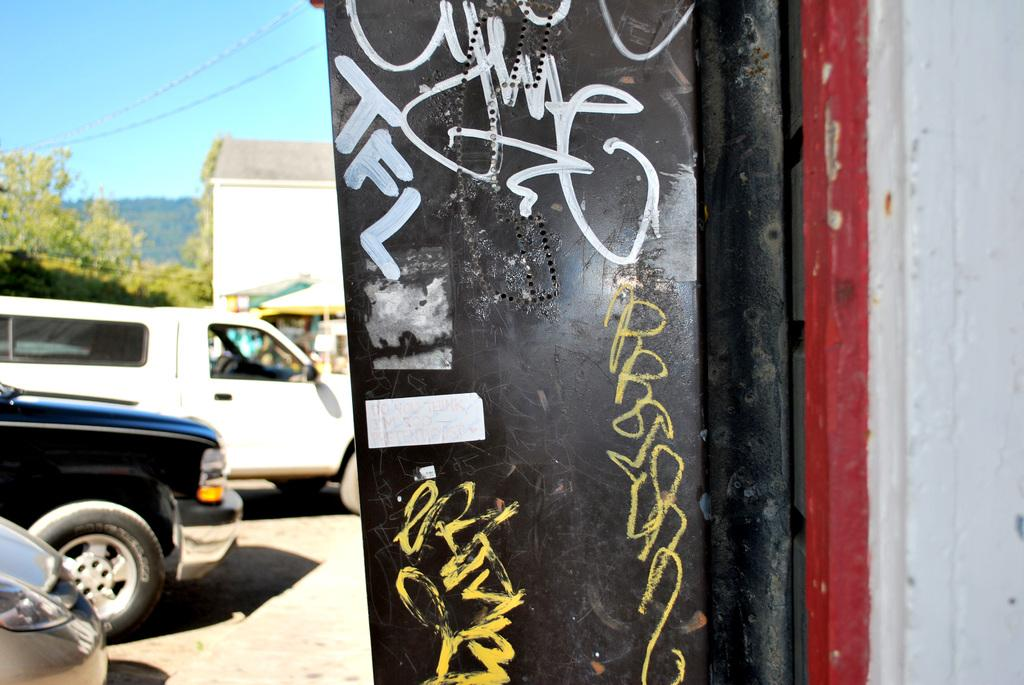What can be seen on the left side of the image? There are vehicles on the left side of the image. What type of natural elements are visible in the image? There are trees visible in the image. What infrastructure elements are present in the image? Electric wires are present in the image. What type of buildings can be seen in the image? There are houses in the image. What metal object is located on the right side of the image? There is a metal object on the right side of the image. What type of songs can be heard coming from the spade in the image? There is no spade present in the image, and therefore no songs can be heard. What type of toys are visible in the image? There is no mention of toys in the provided facts, so we cannot determine if any are visible in the image. 